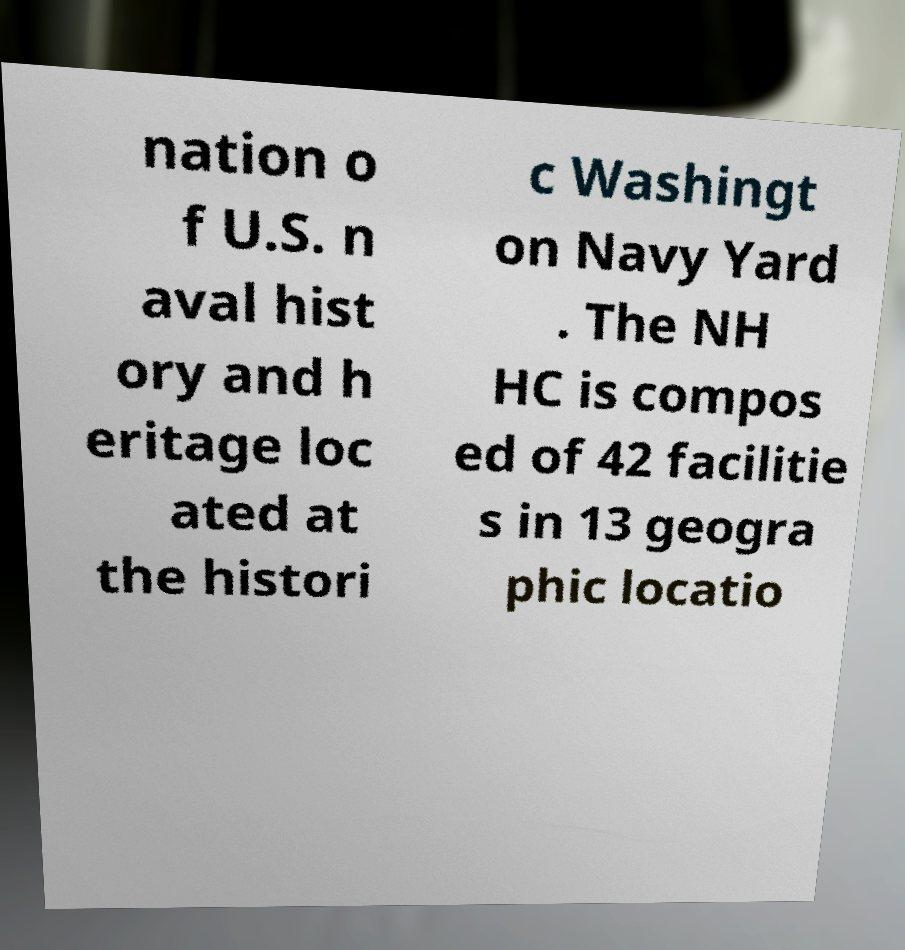Could you assist in decoding the text presented in this image and type it out clearly? nation o f U.S. n aval hist ory and h eritage loc ated at the histori c Washingt on Navy Yard . The NH HC is compos ed of 42 facilitie s in 13 geogra phic locatio 